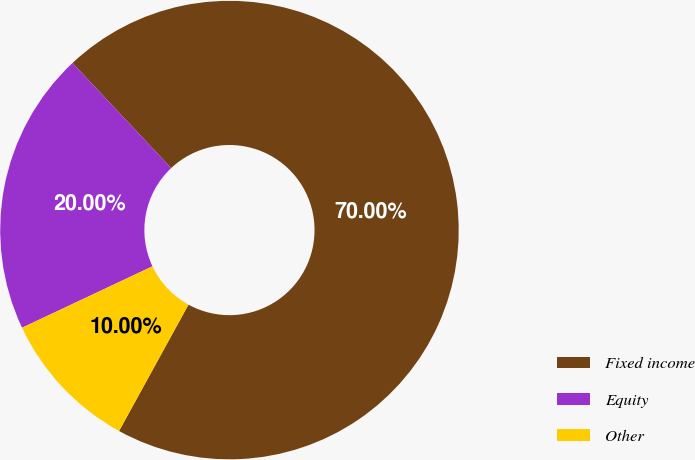Convert chart. <chart><loc_0><loc_0><loc_500><loc_500><pie_chart><fcel>Fixed income<fcel>Equity<fcel>Other<nl><fcel>70.0%<fcel>20.0%<fcel>10.0%<nl></chart> 